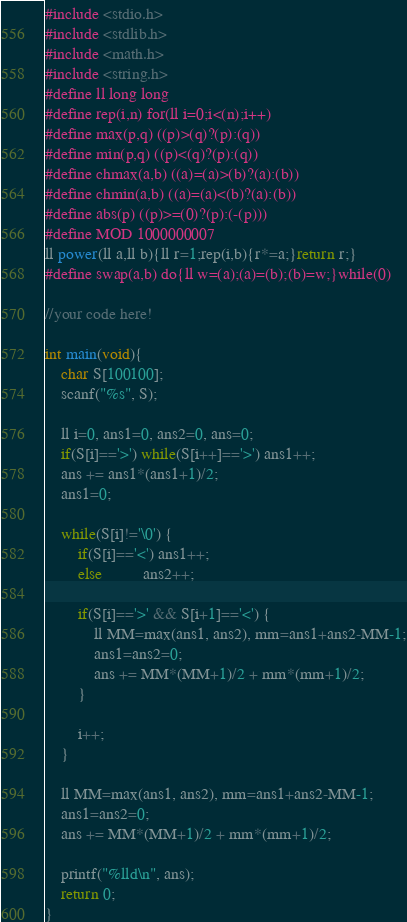Convert code to text. <code><loc_0><loc_0><loc_500><loc_500><_C_>#include <stdio.h>
#include <stdlib.h>
#include <math.h>
#include <string.h>
#define ll long long
#define rep(i,n) for(ll i=0;i<(n);i++)
#define max(p,q) ((p)>(q)?(p):(q))
#define min(p,q) ((p)<(q)?(p):(q))
#define chmax(a,b) ((a)=(a)>(b)?(a):(b))
#define chmin(a,b) ((a)=(a)<(b)?(a):(b))
#define abs(p) ((p)>=(0)?(p):(-(p)))
#define MOD 1000000007
ll power(ll a,ll b){ll r=1;rep(i,b){r*=a;}return r;}
#define swap(a,b) do{ll w=(a);(a)=(b);(b)=w;}while(0)

//your code here!

int main(void){
    char S[100100];
    scanf("%s", S);

    ll i=0, ans1=0, ans2=0, ans=0;
    if(S[i]=='>') while(S[i++]=='>') ans1++;
    ans += ans1*(ans1+1)/2;
    ans1=0;
    
    while(S[i]!='\0') {
        if(S[i]=='<') ans1++;
        else          ans2++;

        if(S[i]=='>' && S[i+1]=='<') {
            ll MM=max(ans1, ans2), mm=ans1+ans2-MM-1;
            ans1=ans2=0;
            ans += MM*(MM+1)/2 + mm*(mm+1)/2;
        }

        i++;
    }

    ll MM=max(ans1, ans2), mm=ans1+ans2-MM-1;
    ans1=ans2=0;
    ans += MM*(MM+1)/2 + mm*(mm+1)/2;

    printf("%lld\n", ans);
    return 0;
}
</code> 